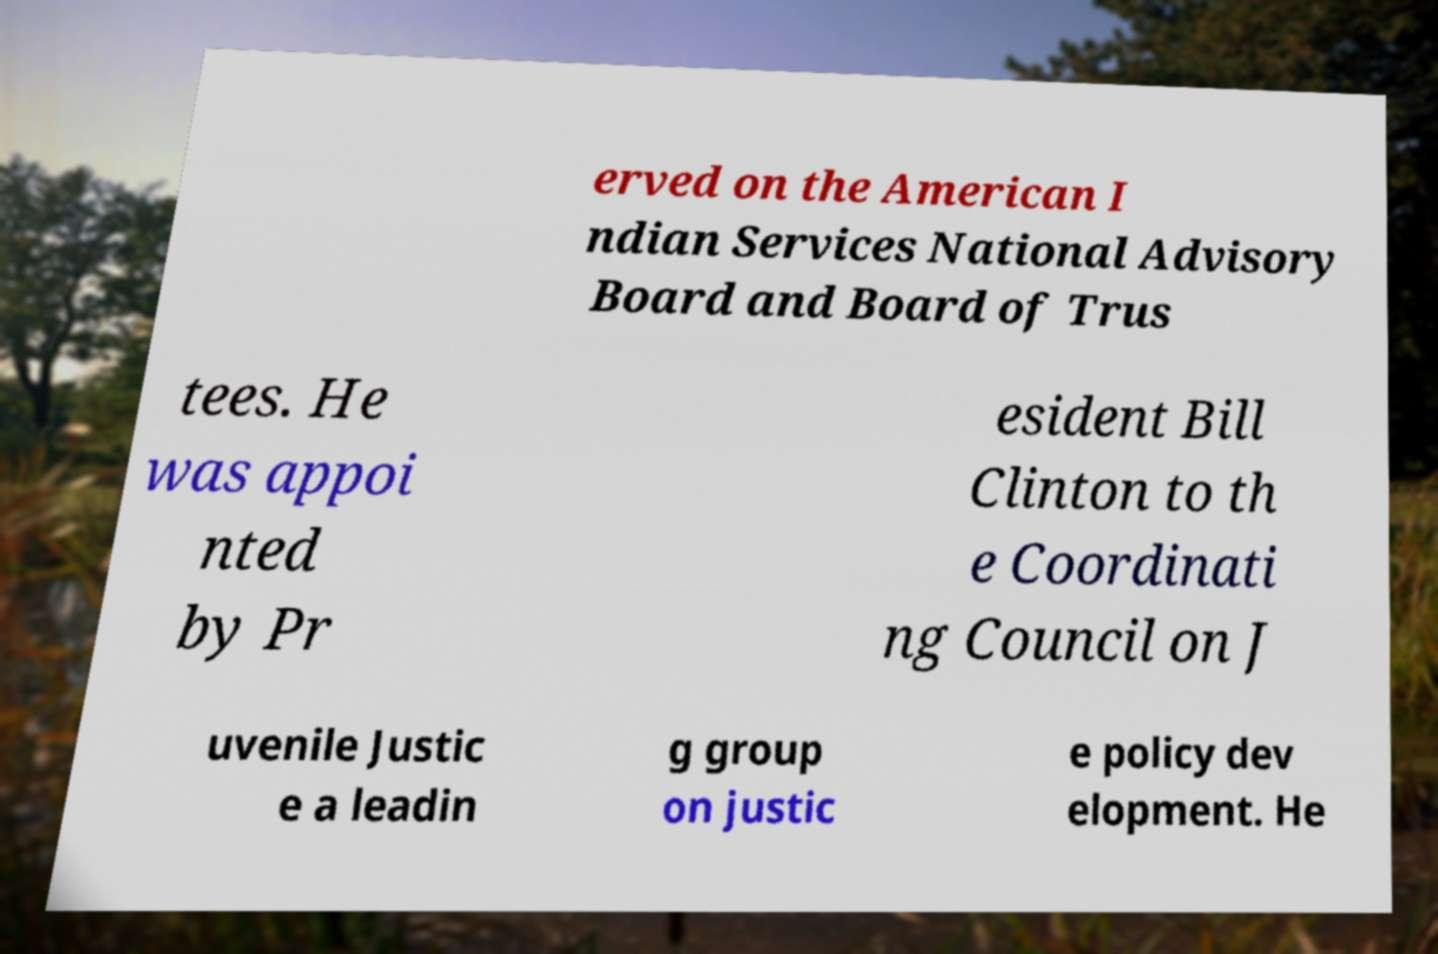Could you assist in decoding the text presented in this image and type it out clearly? erved on the American I ndian Services National Advisory Board and Board of Trus tees. He was appoi nted by Pr esident Bill Clinton to th e Coordinati ng Council on J uvenile Justic e a leadin g group on justic e policy dev elopment. He 